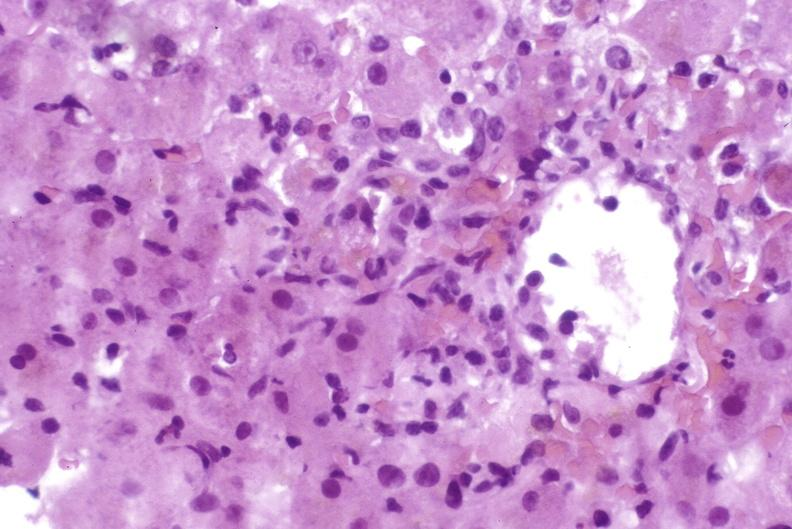what is present?
Answer the question using a single word or phrase. Hepatobiliary 